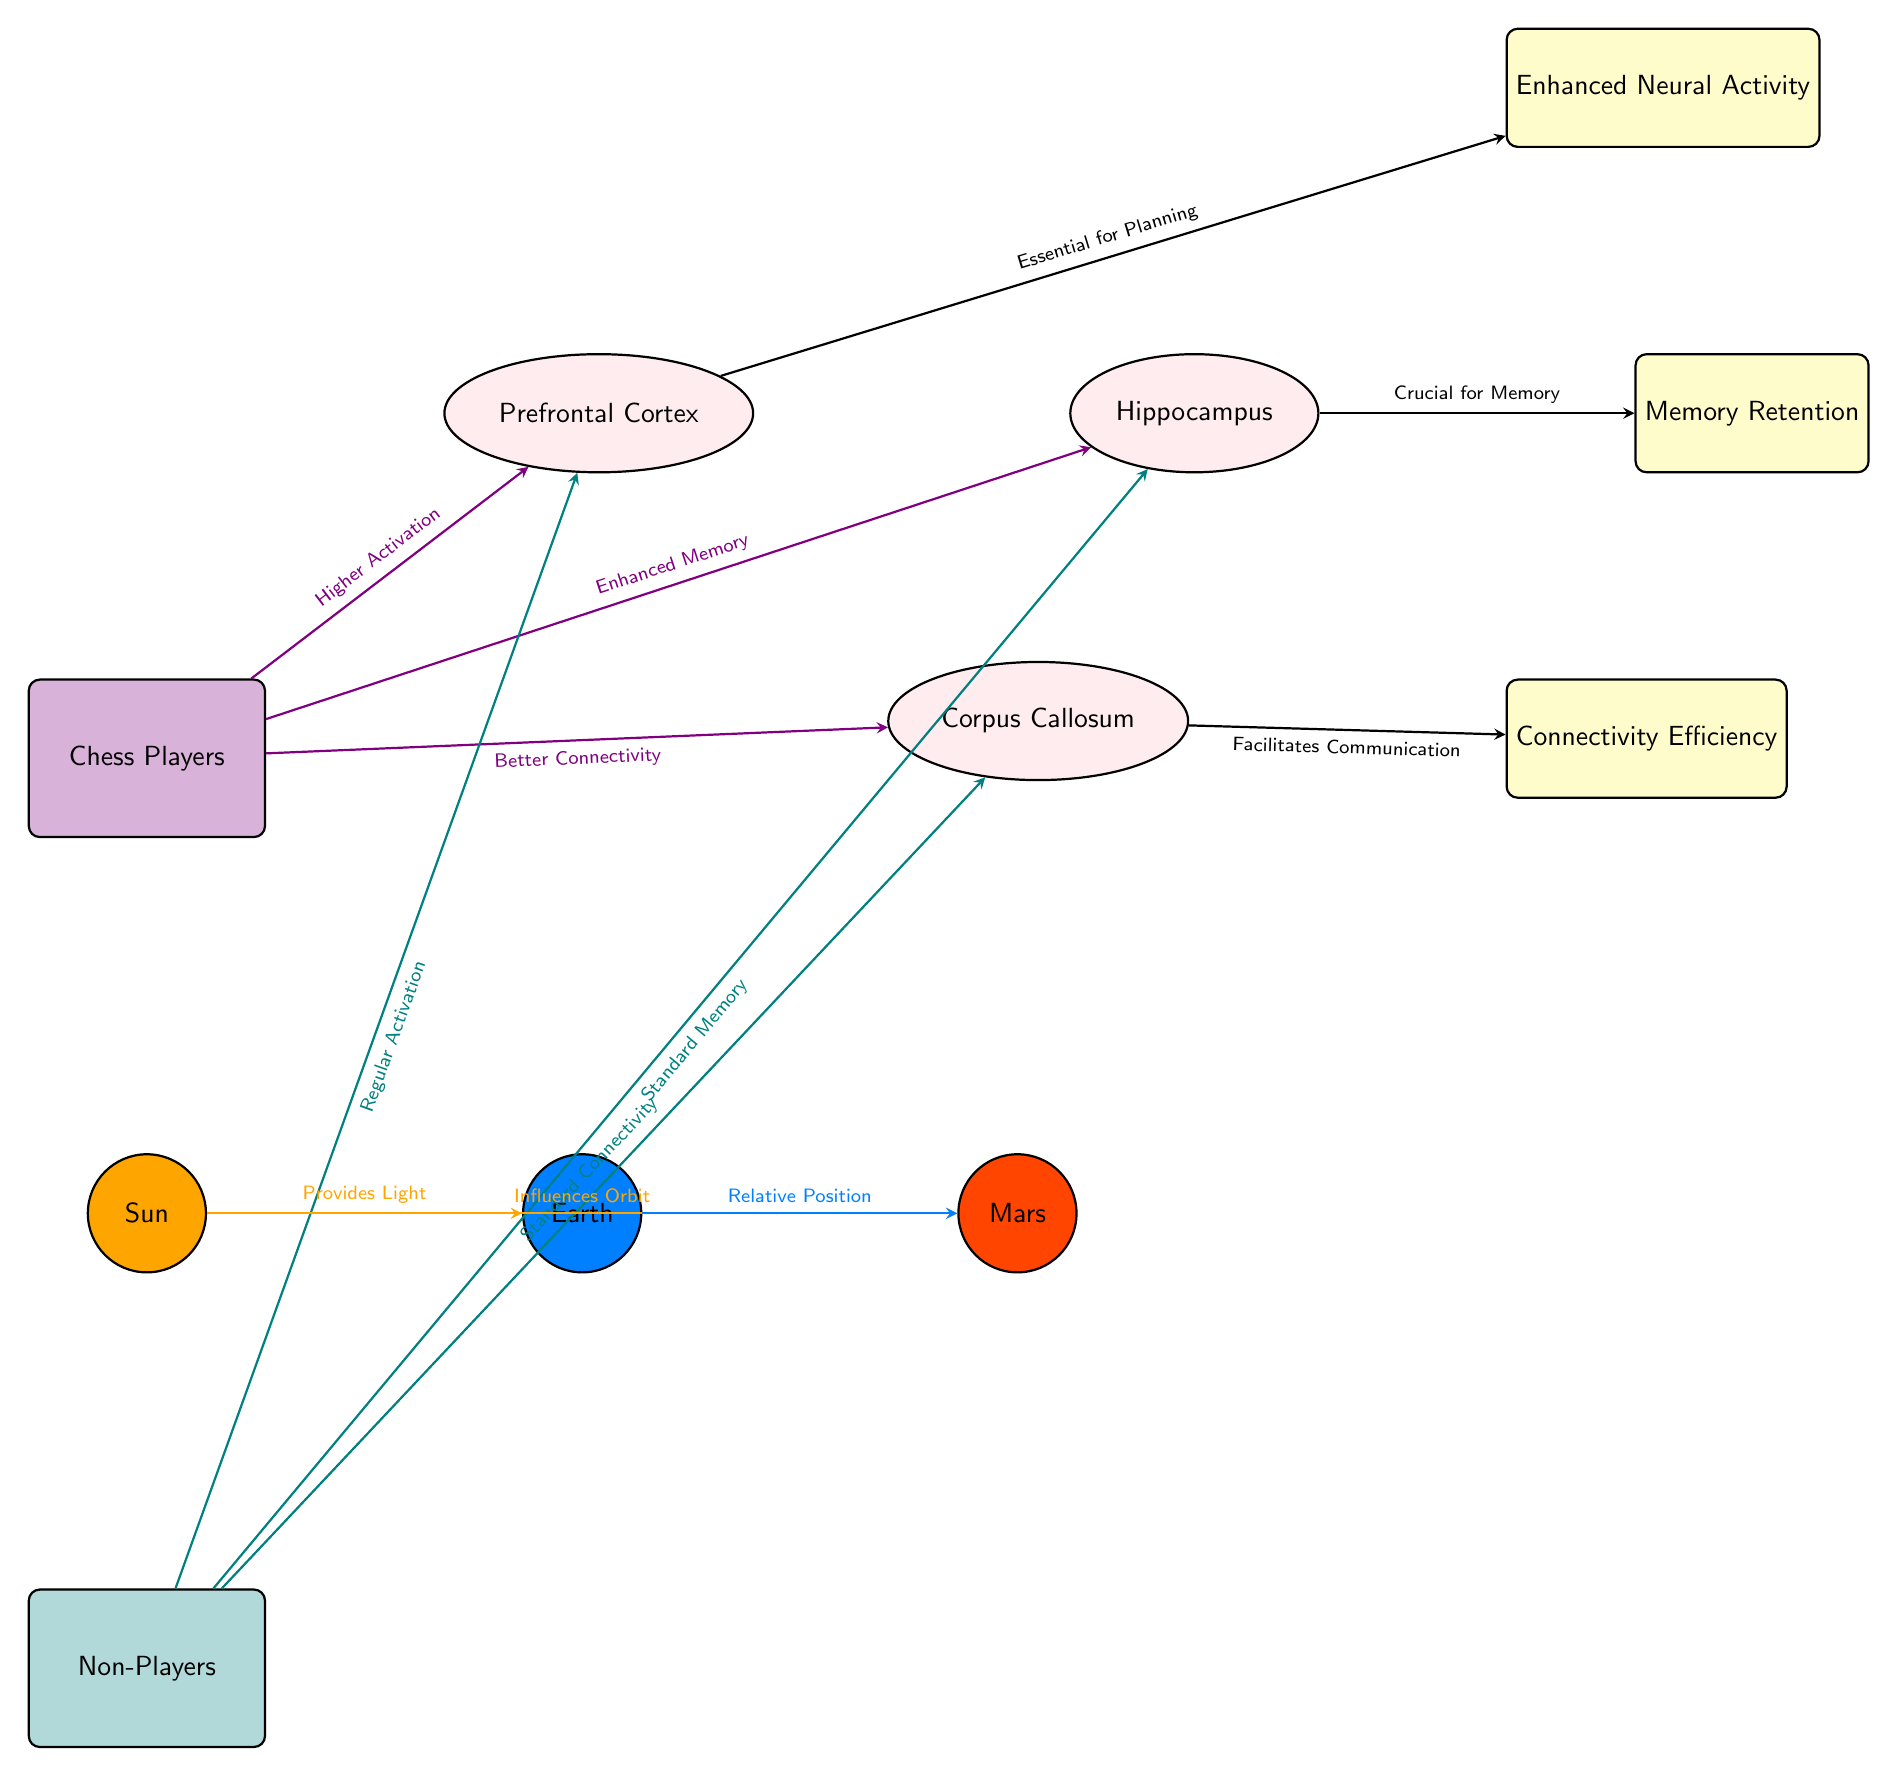What is the color representing Chess Players? The Chess Players group is filled with a shade of purple, denoted by the color code for chesscolor in the diagram.
Answer: purple What brain region is associated with Enhanced Neural Activity? Enhanced Neural Activity is linked to the Prefrontal Cortex, as indicated by the arrow connecting them.
Answer: Prefrontal Cortex How many brain regions are shown in the diagram? The diagram displays three distinct brain regions: Prefrontal Cortex, Hippocampus, and Corpus Callosum. Counting these gives a total of three regions.
Answer: 3 What is the effect depicted from the Hippocampus? The arrow from the Hippocampus points to the effect labeled Memory Retention, indicating this relationship.
Answer: Memory Retention Which planet influences the orbit of Mars? The Sun has an arrow pointing to Mars labeled "Influences Orbit," which shows that it affects Mars' orbital path.
Answer: Sun What is the relationship between Chess Players and the Prefrontal Cortex? The diagram shows an upward arrow from Chess Players to Prefrontal Cortex, labeled “Higher Activation,” indicating a direct relationship.
Answer: Higher Activation What is the significance of the Corpus Callosum for Non-Players? The arrow leading from Non-Players to the Corpus Callosum is labeled “Standard Connectivity,” showing its importance for this group.
Answer: Standard Connectivity Which celestial body provides light according to the diagram? The Sun is depicted as providing light to Earth, as denoted by the label on the arrow from the Sun to Earth.
Answer: Sun What color represents Non-Players in the diagram? Non-Players are represented by a shade of teal, which is noted by the color code for nonplayercolor in the diagram.
Answer: teal 